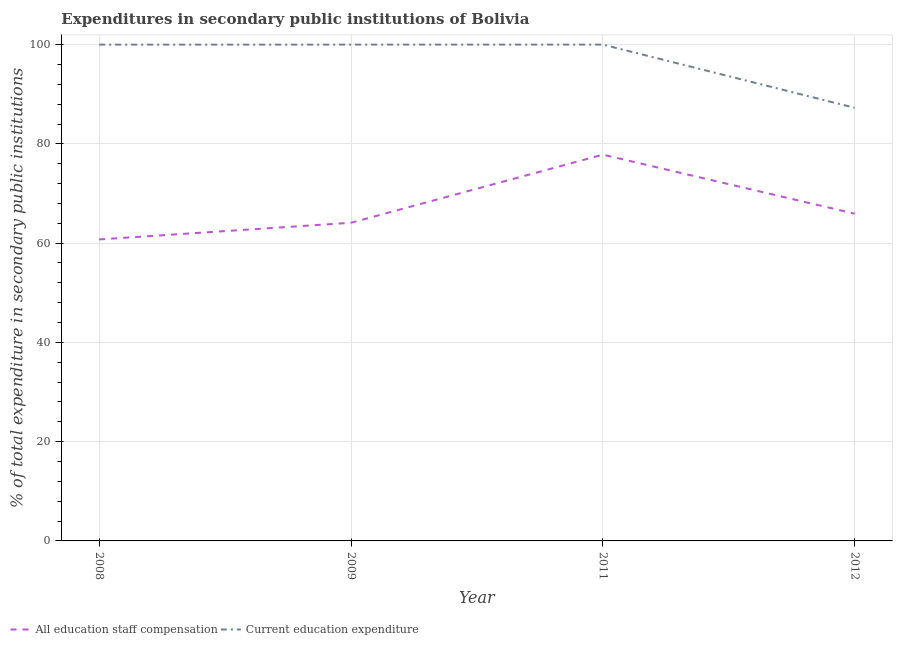What is the expenditure in staff compensation in 2012?
Offer a very short reply. 65.94. Across all years, what is the maximum expenditure in education?
Your answer should be very brief. 100. Across all years, what is the minimum expenditure in education?
Ensure brevity in your answer.  87.27. What is the total expenditure in education in the graph?
Make the answer very short. 387.26. What is the difference between the expenditure in education in 2012 and the expenditure in staff compensation in 2009?
Offer a very short reply. 23.16. What is the average expenditure in education per year?
Your answer should be compact. 96.82. In the year 2012, what is the difference between the expenditure in staff compensation and expenditure in education?
Ensure brevity in your answer.  -21.33. What is the ratio of the expenditure in education in 2011 to that in 2012?
Your answer should be very brief. 1.15. What is the difference between the highest and the second highest expenditure in staff compensation?
Offer a very short reply. 11.89. What is the difference between the highest and the lowest expenditure in staff compensation?
Ensure brevity in your answer.  17.08. Does the expenditure in staff compensation monotonically increase over the years?
Offer a terse response. No. How many lines are there?
Give a very brief answer. 2. How many years are there in the graph?
Your answer should be very brief. 4. What is the difference between two consecutive major ticks on the Y-axis?
Keep it short and to the point. 20. Does the graph contain any zero values?
Give a very brief answer. No. How many legend labels are there?
Keep it short and to the point. 2. What is the title of the graph?
Provide a short and direct response. Expenditures in secondary public institutions of Bolivia. What is the label or title of the Y-axis?
Provide a succinct answer. % of total expenditure in secondary public institutions. What is the % of total expenditure in secondary public institutions in All education staff compensation in 2008?
Give a very brief answer. 60.75. What is the % of total expenditure in secondary public institutions of Current education expenditure in 2008?
Your answer should be very brief. 100. What is the % of total expenditure in secondary public institutions in All education staff compensation in 2009?
Give a very brief answer. 64.11. What is the % of total expenditure in secondary public institutions in Current education expenditure in 2009?
Your response must be concise. 100. What is the % of total expenditure in secondary public institutions in All education staff compensation in 2011?
Give a very brief answer. 77.83. What is the % of total expenditure in secondary public institutions in All education staff compensation in 2012?
Provide a succinct answer. 65.94. What is the % of total expenditure in secondary public institutions in Current education expenditure in 2012?
Make the answer very short. 87.27. Across all years, what is the maximum % of total expenditure in secondary public institutions of All education staff compensation?
Keep it short and to the point. 77.83. Across all years, what is the minimum % of total expenditure in secondary public institutions of All education staff compensation?
Your answer should be very brief. 60.75. Across all years, what is the minimum % of total expenditure in secondary public institutions in Current education expenditure?
Give a very brief answer. 87.27. What is the total % of total expenditure in secondary public institutions in All education staff compensation in the graph?
Ensure brevity in your answer.  268.61. What is the total % of total expenditure in secondary public institutions in Current education expenditure in the graph?
Your answer should be compact. 387.26. What is the difference between the % of total expenditure in secondary public institutions in All education staff compensation in 2008 and that in 2009?
Ensure brevity in your answer.  -3.36. What is the difference between the % of total expenditure in secondary public institutions of Current education expenditure in 2008 and that in 2009?
Your answer should be compact. -0. What is the difference between the % of total expenditure in secondary public institutions of All education staff compensation in 2008 and that in 2011?
Your answer should be compact. -17.08. What is the difference between the % of total expenditure in secondary public institutions in Current education expenditure in 2008 and that in 2011?
Offer a very short reply. -0. What is the difference between the % of total expenditure in secondary public institutions in All education staff compensation in 2008 and that in 2012?
Keep it short and to the point. -5.19. What is the difference between the % of total expenditure in secondary public institutions of Current education expenditure in 2008 and that in 2012?
Your response must be concise. 12.73. What is the difference between the % of total expenditure in secondary public institutions in All education staff compensation in 2009 and that in 2011?
Provide a short and direct response. -13.72. What is the difference between the % of total expenditure in secondary public institutions in All education staff compensation in 2009 and that in 2012?
Provide a succinct answer. -1.83. What is the difference between the % of total expenditure in secondary public institutions in Current education expenditure in 2009 and that in 2012?
Offer a terse response. 12.73. What is the difference between the % of total expenditure in secondary public institutions in All education staff compensation in 2011 and that in 2012?
Your response must be concise. 11.89. What is the difference between the % of total expenditure in secondary public institutions in Current education expenditure in 2011 and that in 2012?
Make the answer very short. 12.73. What is the difference between the % of total expenditure in secondary public institutions of All education staff compensation in 2008 and the % of total expenditure in secondary public institutions of Current education expenditure in 2009?
Make the answer very short. -39.25. What is the difference between the % of total expenditure in secondary public institutions of All education staff compensation in 2008 and the % of total expenditure in secondary public institutions of Current education expenditure in 2011?
Keep it short and to the point. -39.25. What is the difference between the % of total expenditure in secondary public institutions in All education staff compensation in 2008 and the % of total expenditure in secondary public institutions in Current education expenditure in 2012?
Keep it short and to the point. -26.52. What is the difference between the % of total expenditure in secondary public institutions of All education staff compensation in 2009 and the % of total expenditure in secondary public institutions of Current education expenditure in 2011?
Give a very brief answer. -35.89. What is the difference between the % of total expenditure in secondary public institutions in All education staff compensation in 2009 and the % of total expenditure in secondary public institutions in Current education expenditure in 2012?
Your answer should be very brief. -23.16. What is the difference between the % of total expenditure in secondary public institutions of All education staff compensation in 2011 and the % of total expenditure in secondary public institutions of Current education expenditure in 2012?
Make the answer very short. -9.44. What is the average % of total expenditure in secondary public institutions of All education staff compensation per year?
Provide a short and direct response. 67.15. What is the average % of total expenditure in secondary public institutions in Current education expenditure per year?
Provide a succinct answer. 96.82. In the year 2008, what is the difference between the % of total expenditure in secondary public institutions of All education staff compensation and % of total expenditure in secondary public institutions of Current education expenditure?
Keep it short and to the point. -39.25. In the year 2009, what is the difference between the % of total expenditure in secondary public institutions in All education staff compensation and % of total expenditure in secondary public institutions in Current education expenditure?
Keep it short and to the point. -35.89. In the year 2011, what is the difference between the % of total expenditure in secondary public institutions of All education staff compensation and % of total expenditure in secondary public institutions of Current education expenditure?
Provide a succinct answer. -22.17. In the year 2012, what is the difference between the % of total expenditure in secondary public institutions in All education staff compensation and % of total expenditure in secondary public institutions in Current education expenditure?
Your answer should be compact. -21.33. What is the ratio of the % of total expenditure in secondary public institutions of All education staff compensation in 2008 to that in 2009?
Offer a very short reply. 0.95. What is the ratio of the % of total expenditure in secondary public institutions of Current education expenditure in 2008 to that in 2009?
Your answer should be compact. 1. What is the ratio of the % of total expenditure in secondary public institutions in All education staff compensation in 2008 to that in 2011?
Provide a short and direct response. 0.78. What is the ratio of the % of total expenditure in secondary public institutions of All education staff compensation in 2008 to that in 2012?
Give a very brief answer. 0.92. What is the ratio of the % of total expenditure in secondary public institutions in Current education expenditure in 2008 to that in 2012?
Make the answer very short. 1.15. What is the ratio of the % of total expenditure in secondary public institutions in All education staff compensation in 2009 to that in 2011?
Make the answer very short. 0.82. What is the ratio of the % of total expenditure in secondary public institutions in All education staff compensation in 2009 to that in 2012?
Make the answer very short. 0.97. What is the ratio of the % of total expenditure in secondary public institutions in Current education expenditure in 2009 to that in 2012?
Keep it short and to the point. 1.15. What is the ratio of the % of total expenditure in secondary public institutions in All education staff compensation in 2011 to that in 2012?
Make the answer very short. 1.18. What is the ratio of the % of total expenditure in secondary public institutions in Current education expenditure in 2011 to that in 2012?
Provide a short and direct response. 1.15. What is the difference between the highest and the second highest % of total expenditure in secondary public institutions of All education staff compensation?
Keep it short and to the point. 11.89. What is the difference between the highest and the lowest % of total expenditure in secondary public institutions in All education staff compensation?
Your answer should be very brief. 17.08. What is the difference between the highest and the lowest % of total expenditure in secondary public institutions of Current education expenditure?
Your answer should be very brief. 12.73. 